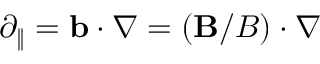Convert formula to latex. <formula><loc_0><loc_0><loc_500><loc_500>\partial _ { \| } = b \cdot \nabla = ( B / B ) \cdot \nabla</formula> 